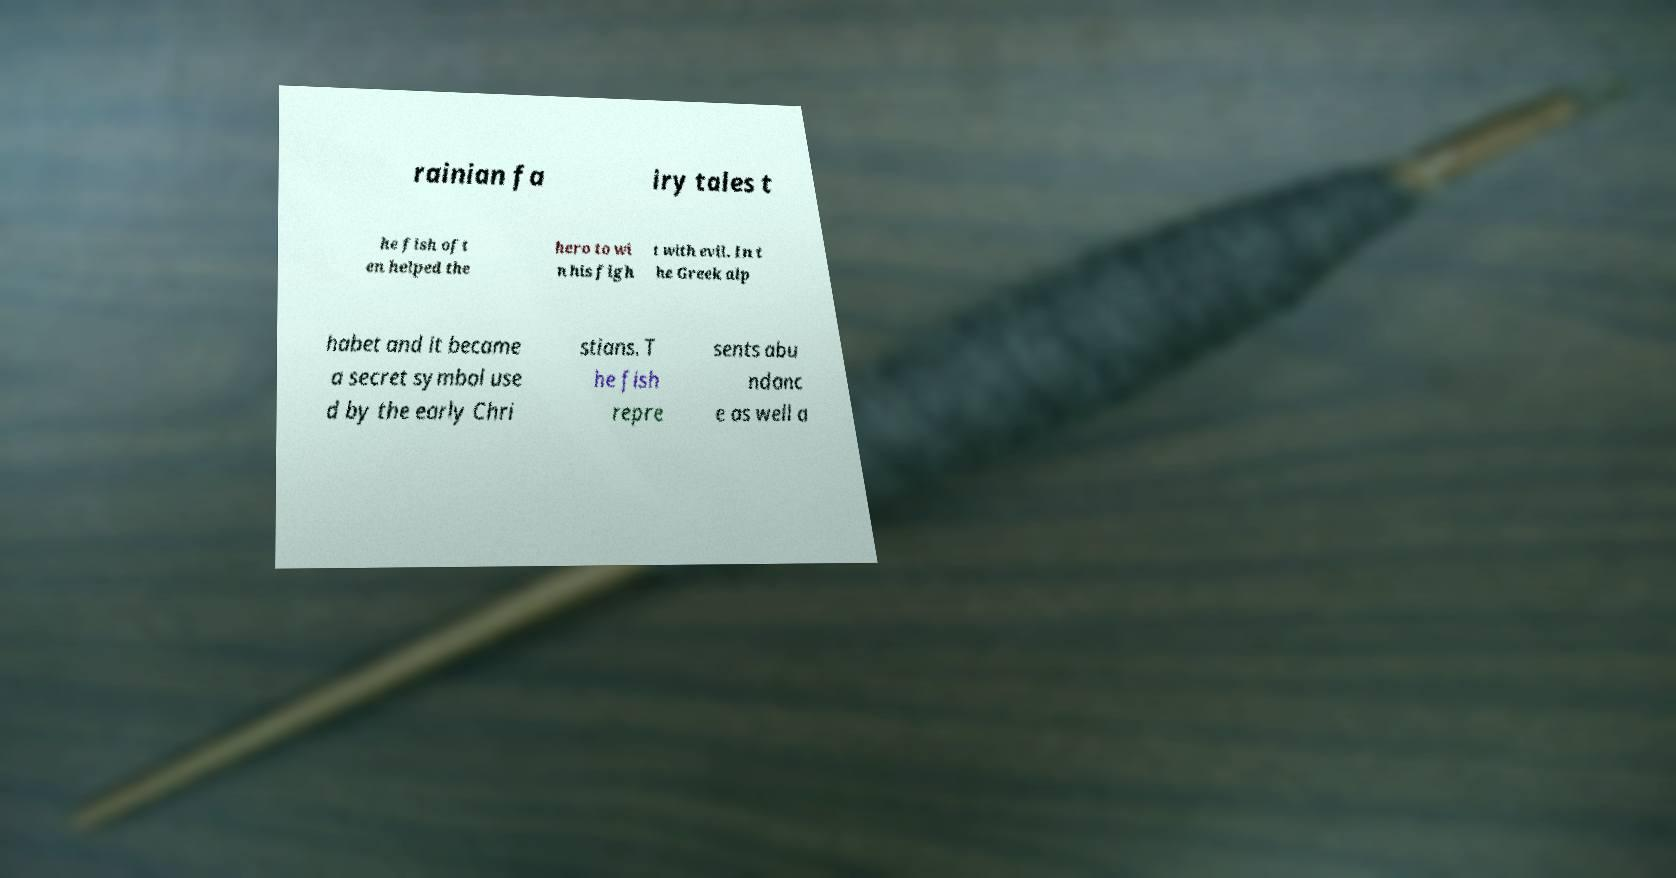Can you accurately transcribe the text from the provided image for me? rainian fa iry tales t he fish oft en helped the hero to wi n his figh t with evil. In t he Greek alp habet and it became a secret symbol use d by the early Chri stians. T he fish repre sents abu ndanc e as well a 